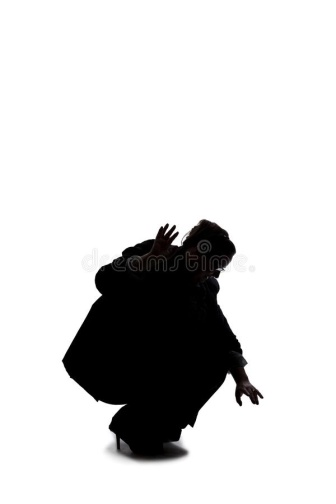What do you think the person in the image might be getting ready to do? The person in the image appears to be in a position of readiness, crouched with their arms extended, as if preparing to spring into action. They could be engaging in a physical activity that requires agility and quick movement, such as a dance, martial art, or even a dramatic stealthy maneuver. The particular stance and the expression of their hands suggest a moment filled with potential energy, as if they are about to leap forward or catch something unseen to the viewer. 